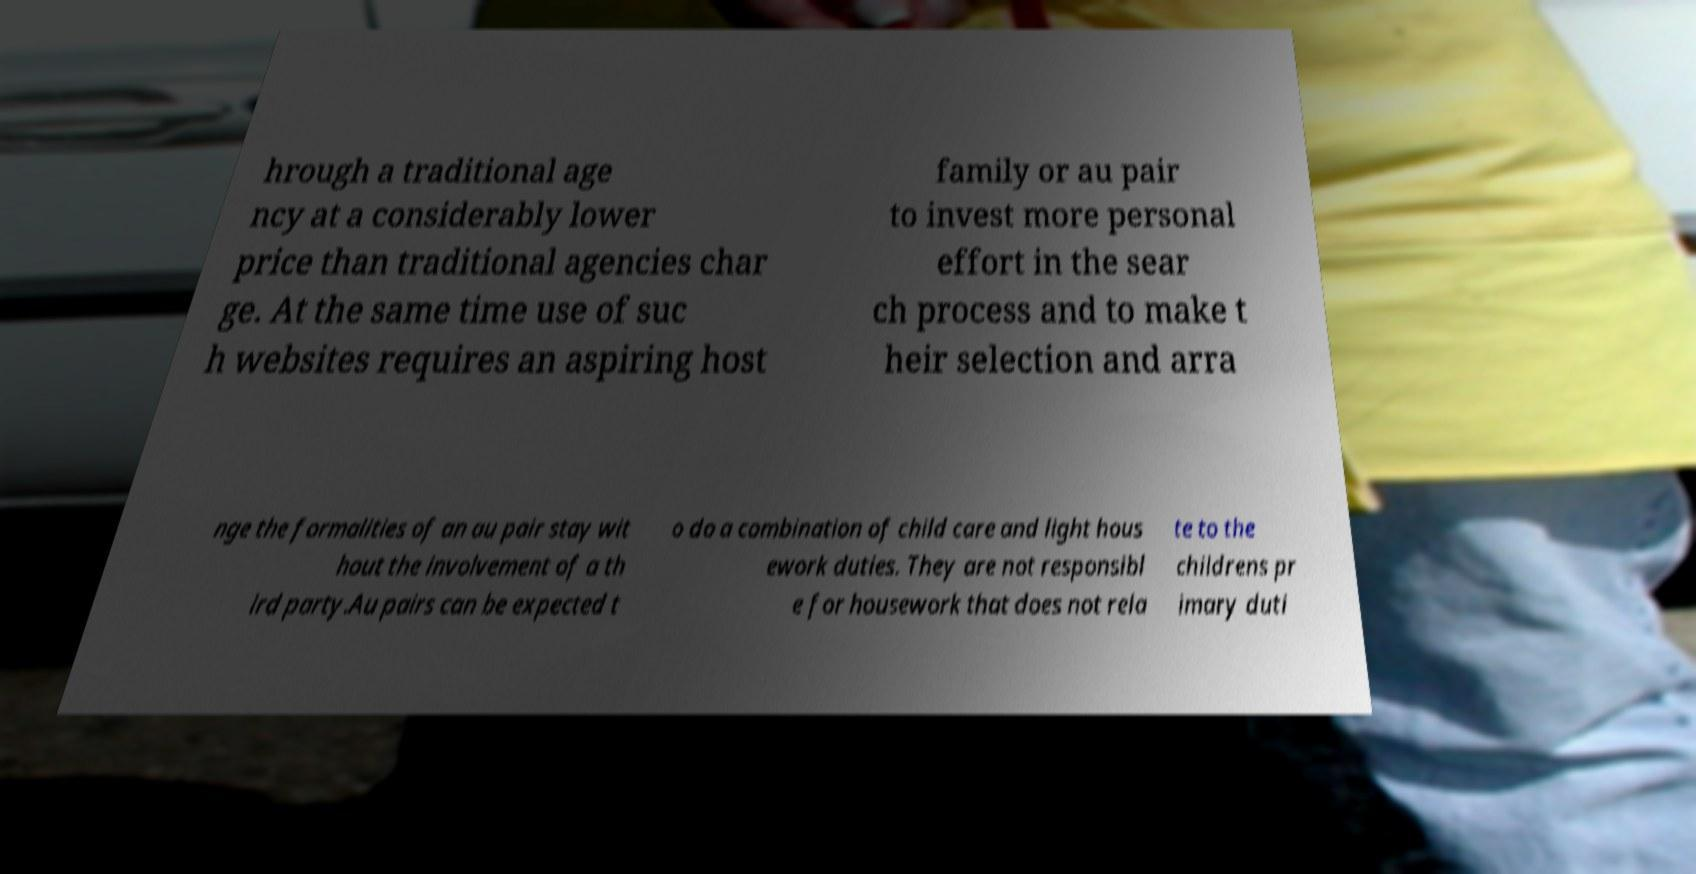Can you read and provide the text displayed in the image?This photo seems to have some interesting text. Can you extract and type it out for me? hrough a traditional age ncy at a considerably lower price than traditional agencies char ge. At the same time use of suc h websites requires an aspiring host family or au pair to invest more personal effort in the sear ch process and to make t heir selection and arra nge the formalities of an au pair stay wit hout the involvement of a th ird party.Au pairs can be expected t o do a combination of child care and light hous ework duties. They are not responsibl e for housework that does not rela te to the childrens pr imary duti 